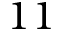<formula> <loc_0><loc_0><loc_500><loc_500>1 1</formula> 